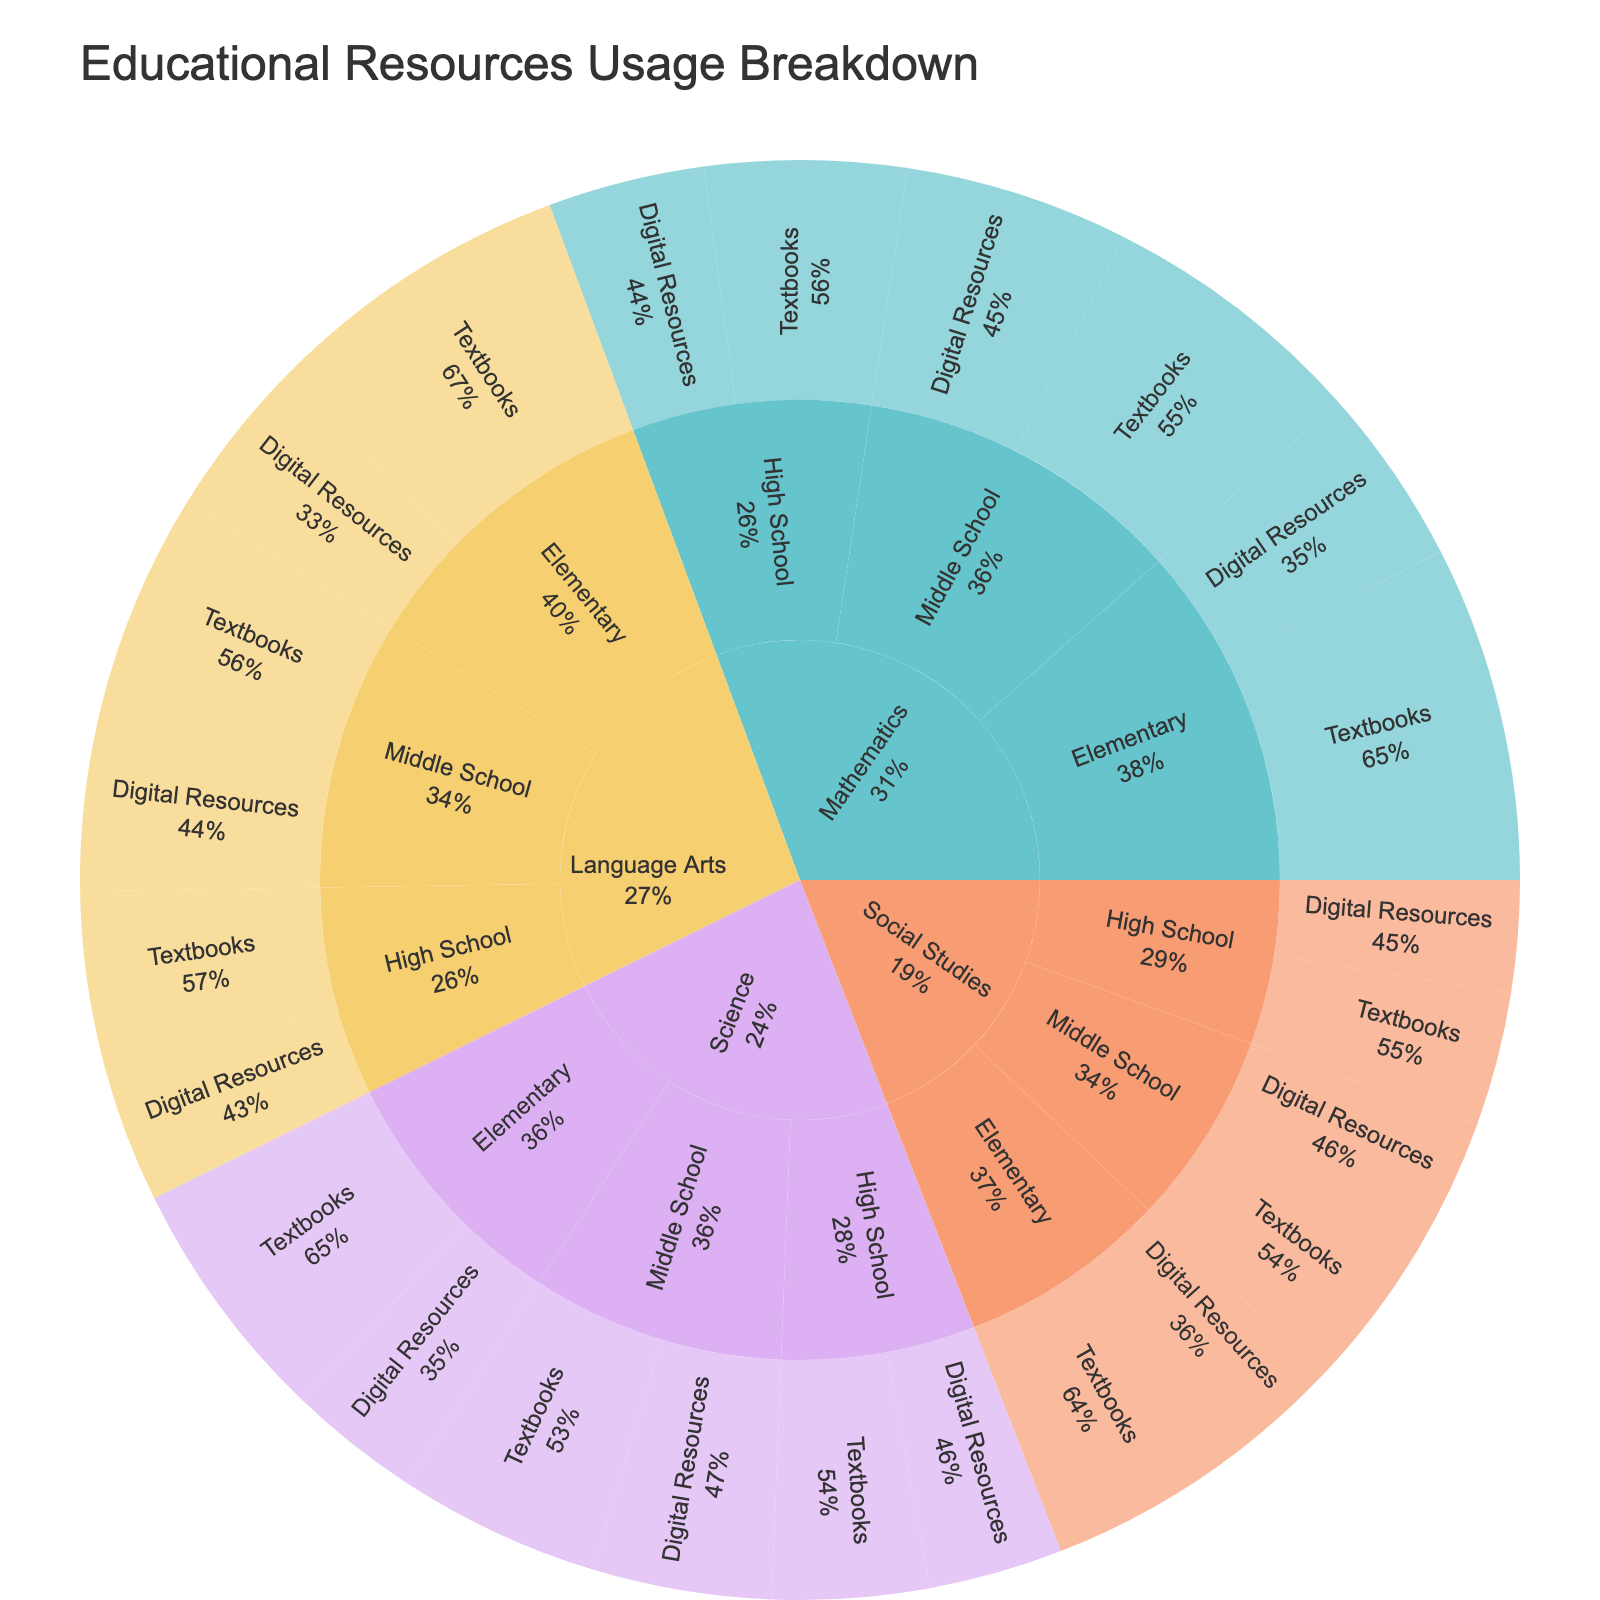What is the most used educational resource format for Mathematics at the Elementary level? The sunburst plot shows the breakdown by subject, grade level, and format. For Mathematics at the Elementary level, the segment with the highest percentage represents Textbooks.
Answer: Textbooks Which subject has the highest overall usage percentage of Digital Resources? By looking at the outermost segments categorized by subject and summing the usage percentages of Digital Resources across all grade levels, Mathematics (8% + 10% + 7% = 25%) has a higher sum compared to others.
Answer: Mathematics What is the total usage percentage of Textbooks for Language Arts? Adding the usage percentages of Textbooks for all grade levels in Language Arts: Elementary (14%) + Middle School (10%) + High School (8%) = 32%.
Answer: 32% Which grade level uses the least amount of Digital Resources for Science? Examining the outer rings for Science and comparing the Digital Resources segments: Elementary (6%), Middle School (8%), and High School (6%). Both Elementary and High School have the least usage at 6%.
Answer: Elementary and High School Compare the usage percentage of Digital Resources for Social Studies in Middle School and High School. Which one is higher? The sunburst plot shows Social Studies segments for Middle School (6%) and High School (5%) in Digital Resources. Middle School is higher.
Answer: Middle School How does the usage percentage of Textbooks for Science in High School compare to that of Mathematics in High School? The figure shows that the Textbook usage for Science in High School is 7%, while for Mathematics in High School, it is 9%. Mathematics is higher.
Answer: Mathematics is higher What is the least used educational resource format across all subjects and grade levels? By examining the outermost segments of the sunburst plot, we can see that the lowest usage percentage is for Social Studies Digital Resources in High School, at 5%.
Answer: Social Studies Digital Resources in High School Calculate the total usage percentage of all educational resources for Elementary grade level across all subjects. Summing the usage percentages for Elementary: Mathematics (15% + 8%) + Science (11% + 6%) + Language Arts (14% + 7%) + Social Studies (9% + 5%) = 75%.
Answer: 75% Which subject has an equal percentage usage of Textbooks across all grade levels? The plot shows that Social Studies has Textbooks usage as 9% for Elementary, 7% for Middle School, and 6% for High School, which are not equal. There is no subject with equal usage across all grade levels for Textbooks.
Answer: None What is the usage percentage difference of Textbooks between Mathematics and Science at the Middle School level? The figure shows Middle School Textbook usage for Mathematics at 12% and for Science at 9%. The difference is 12% - 9% = 3%.
Answer: 3% 